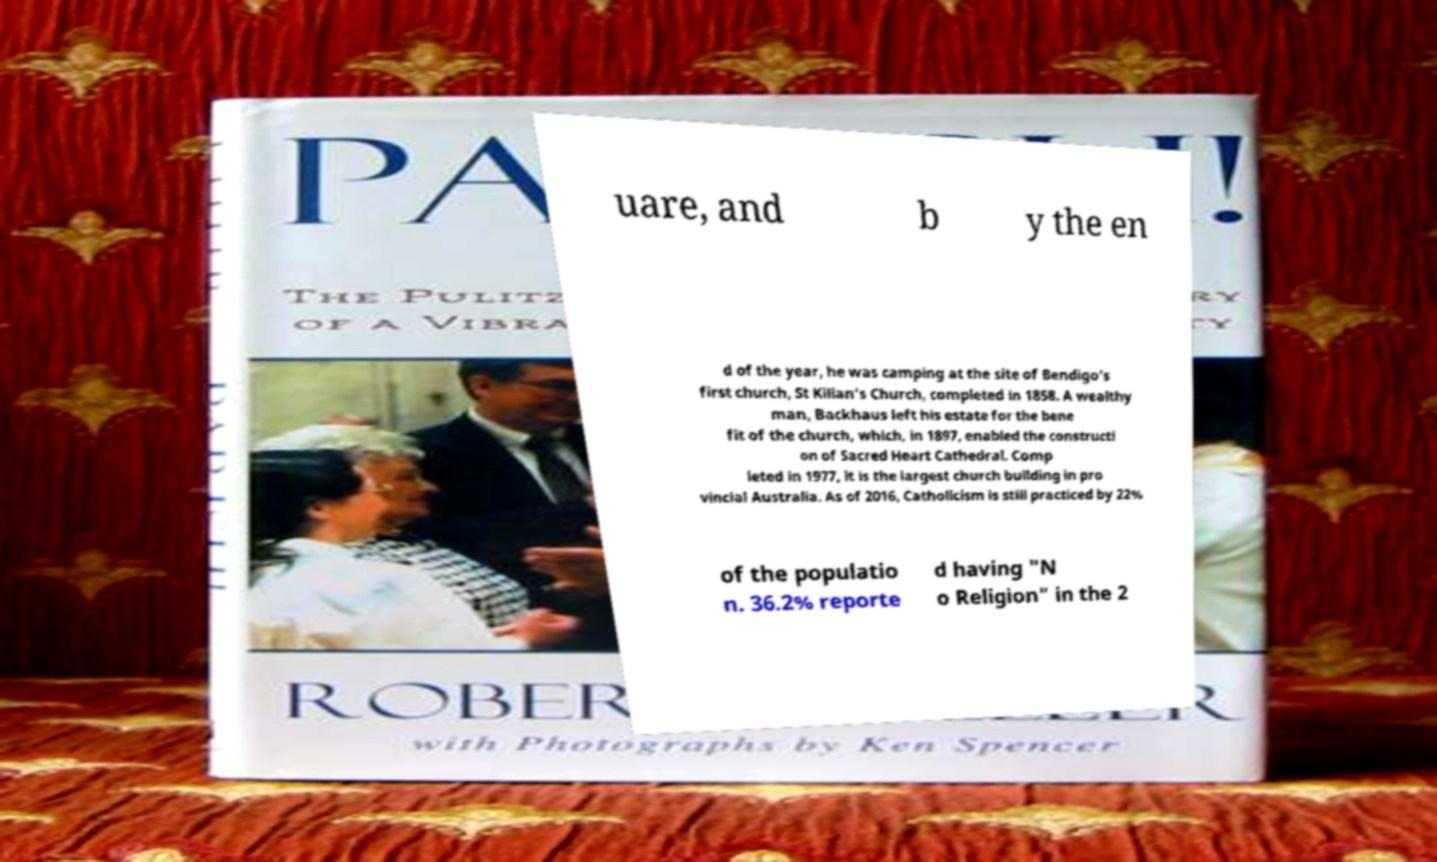For documentation purposes, I need the text within this image transcribed. Could you provide that? uare, and b y the en d of the year, he was camping at the site of Bendigo's first church, St Kilian's Church, completed in 1858. A wealthy man, Backhaus left his estate for the bene fit of the church, which, in 1897, enabled the constructi on of Sacred Heart Cathedral. Comp leted in 1977, it is the largest church building in pro vincial Australia. As of 2016, Catholicism is still practiced by 22% of the populatio n. 36.2% reporte d having "N o Religion" in the 2 